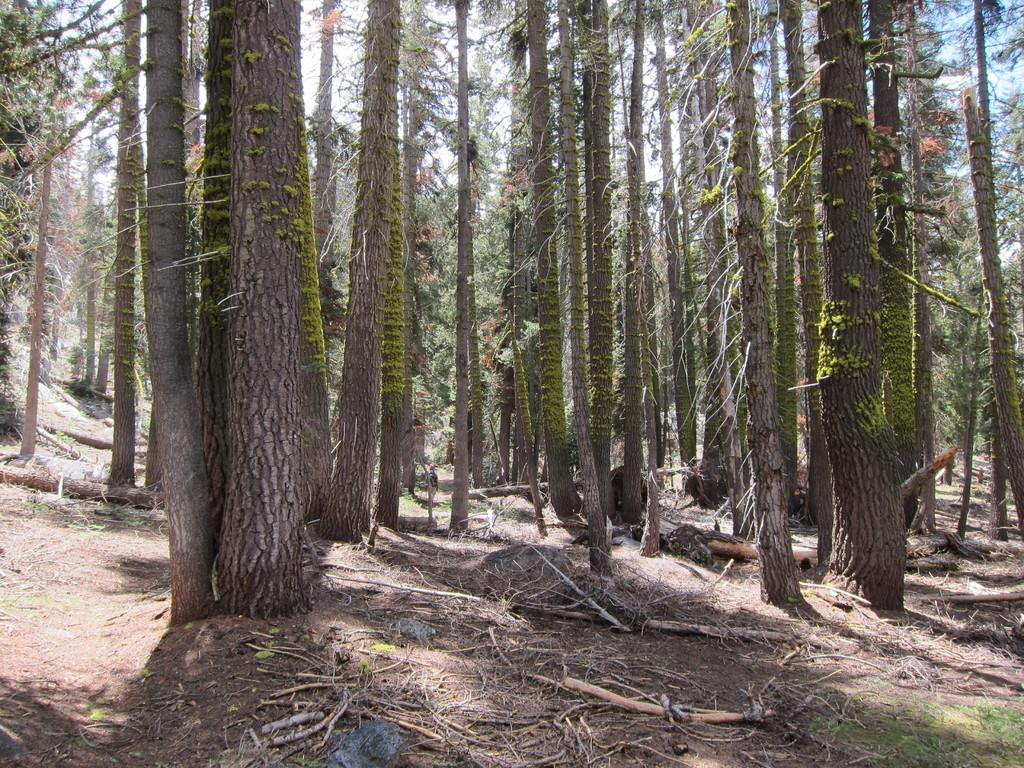What type of vegetation can be seen in the image? There are trees in the image. What is the surface visible in the image? There is a ground visible in the image. What objects are present on the ground? Sticks are present on the ground. What type of plant life is present on the ground? Grass is present on the ground. How many hours of sleep can be seen in the image? There is no indication of sleep or time in the image, so it cannot be determined from the image. 